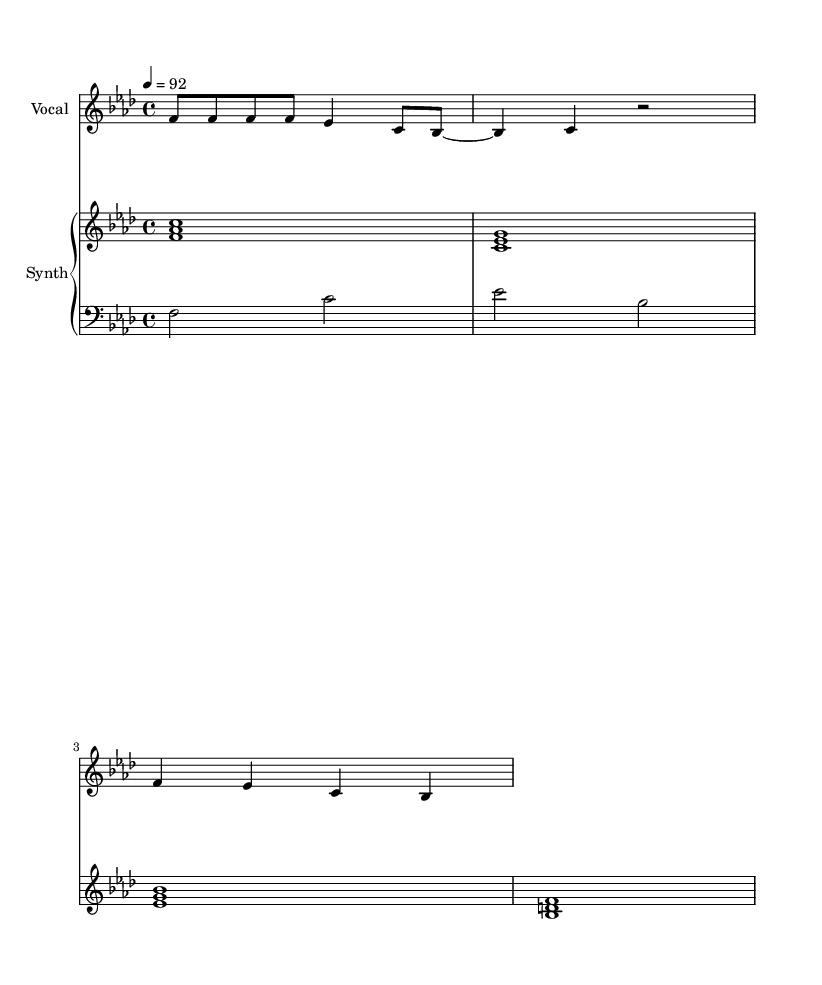What is the key signature of this music? The key signature indicates F minor, which is represented by four flats (B♭, E♭, A♭, D♭) in the sheet music. This is found at the beginning of the staff.
Answer: F minor What is the time signature of this music? The time signature is indicated at the beginning, showing 4/4, which means there are four beats in every measure and the quarter note receives one beat.
Answer: 4/4 What is the tempo marking of this music? The tempo is indicated in the score. It states "4 = 92", meaning there are 92 beats per minute when played at the quarter note value.
Answer: 92 How many measures are in the vocal part? Counting the number of distinct rhythmic patterns or segments in the vocal line reveals that there are four measures outlined by the bar lines.
Answer: 4 What type of music is this? This piece is identified as "Rap," which is conveyed by the style of lyrics and rhythmic speaking patterns included in the sheet music.
Answer: Rap What is the primary emotion expressed in the lyrics? The lyrics convey a humorous and somewhat absurd commentary on urban planning processes, indicated by the playful phrasing related to bureaucratic jargon.
Answer: Humor What is the range of the vocal part? The vocal part starts on F and reaches a high note of B♭, suggesting a range of a minor sixth from F to B♭.
Answer: Minor sixth 